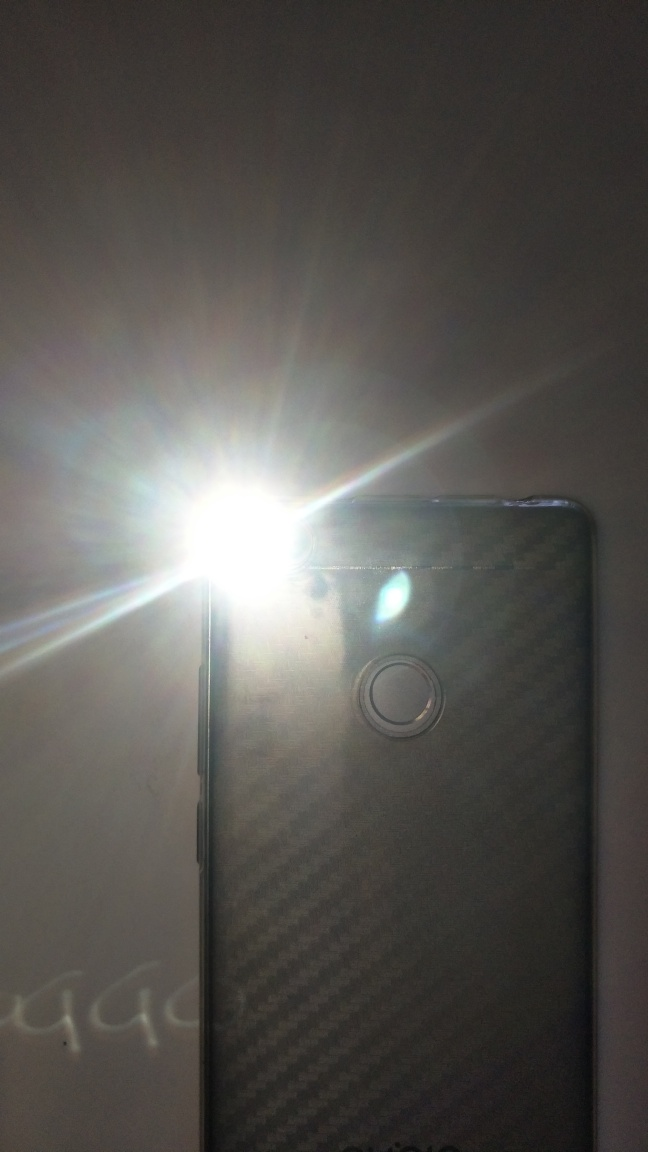Can you tell me about the surface texture of the phone? The phone's back panel appears to have a textured, possibly ribbed or carbon fiber-like design which can provide a better grip and also adds an element of aesthetic appeal to the device. Does the image indicate any specific use case for the flash? While the specific use case for activating the flash isn't clear from the image alone, it could be used for taking photos in low-light conditions, serving as a flashlight, or for signaling in an emergency. 